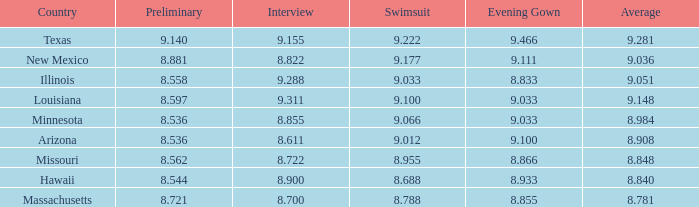848? 8.955. 